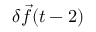Convert formula to latex. <formula><loc_0><loc_0><loc_500><loc_500>\delta \vec { f } ( t - 2 )</formula> 